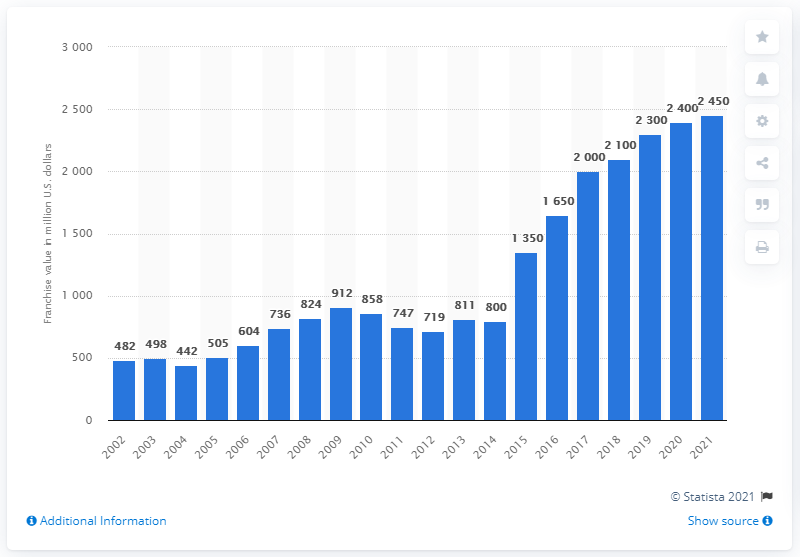Draw attention to some important aspects in this diagram. The estimated value of the New York Mets in 2021 was approximately $2,450. 